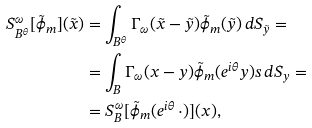Convert formula to latex. <formula><loc_0><loc_0><loc_500><loc_500>S ^ { \omega } _ { B ^ { \theta } } [ \tilde { \phi } _ { m } ] ( \tilde { x } ) & = \int _ { B ^ { \theta } } \Gamma _ { \omega } ( \tilde { x } - \tilde { y } ) \tilde { \phi } _ { m } ( \tilde { y } ) \, d S _ { \tilde { y } } = \\ & = \int _ { B } \Gamma _ { \omega } ( x - y ) \tilde { \phi } _ { m } ( e ^ { i \theta } y ) s \, d S _ { y } = \\ & = S ^ { \omega } _ { B } [ \tilde { \phi } _ { m } ( e ^ { i \theta } \, \cdot ) ] ( x ) ,</formula> 